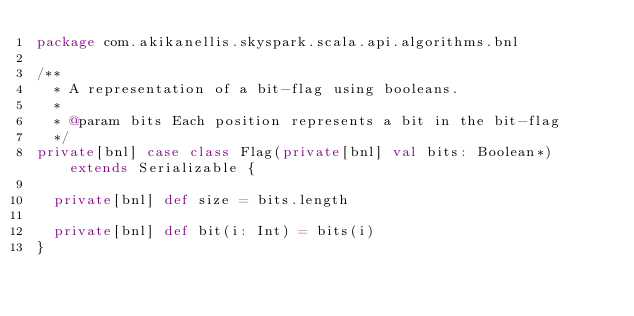Convert code to text. <code><loc_0><loc_0><loc_500><loc_500><_Scala_>package com.akikanellis.skyspark.scala.api.algorithms.bnl

/**
  * A representation of a bit-flag using booleans.
  *
  * @param bits Each position represents a bit in the bit-flag
  */
private[bnl] case class Flag(private[bnl] val bits: Boolean*) extends Serializable {

  private[bnl] def size = bits.length

  private[bnl] def bit(i: Int) = bits(i)
}
</code> 